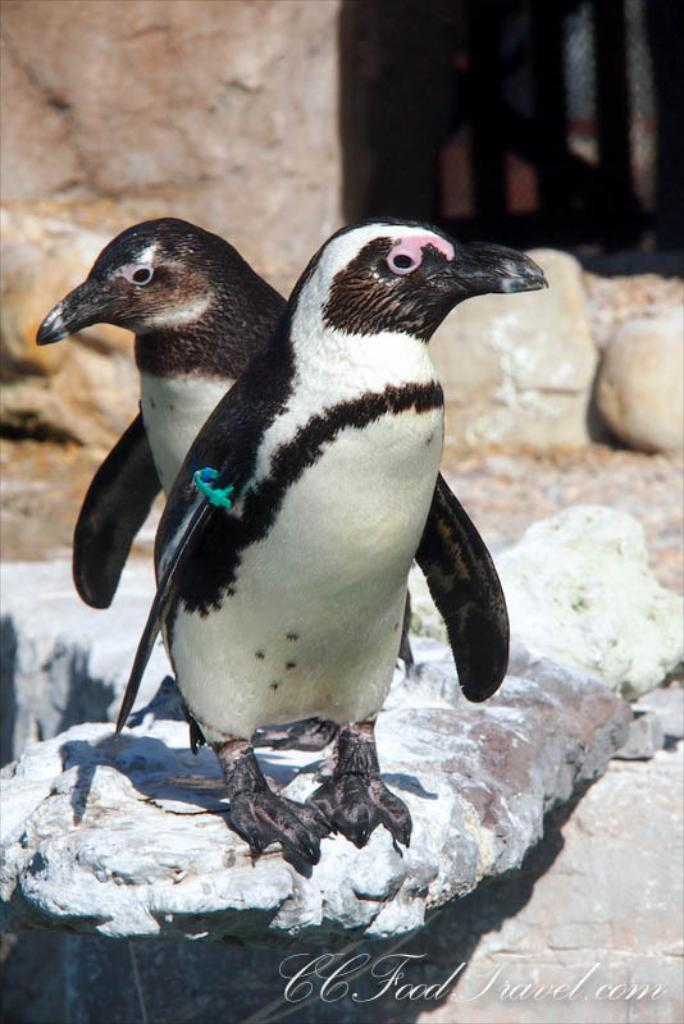What animals are present in the image? There are two penguins in the image. Where are the penguins located? The penguins are on a rock. What can be seen in the background of the image? There is a fence and rocks in the background of the image. Is there any text in the image? Yes, there is text at the bottom of the image. What type of fuel is being used by the cars in the image? There are no cars present in the image; it features two penguins on a rock with a fence and rocks in the background, and text at the bottom. 